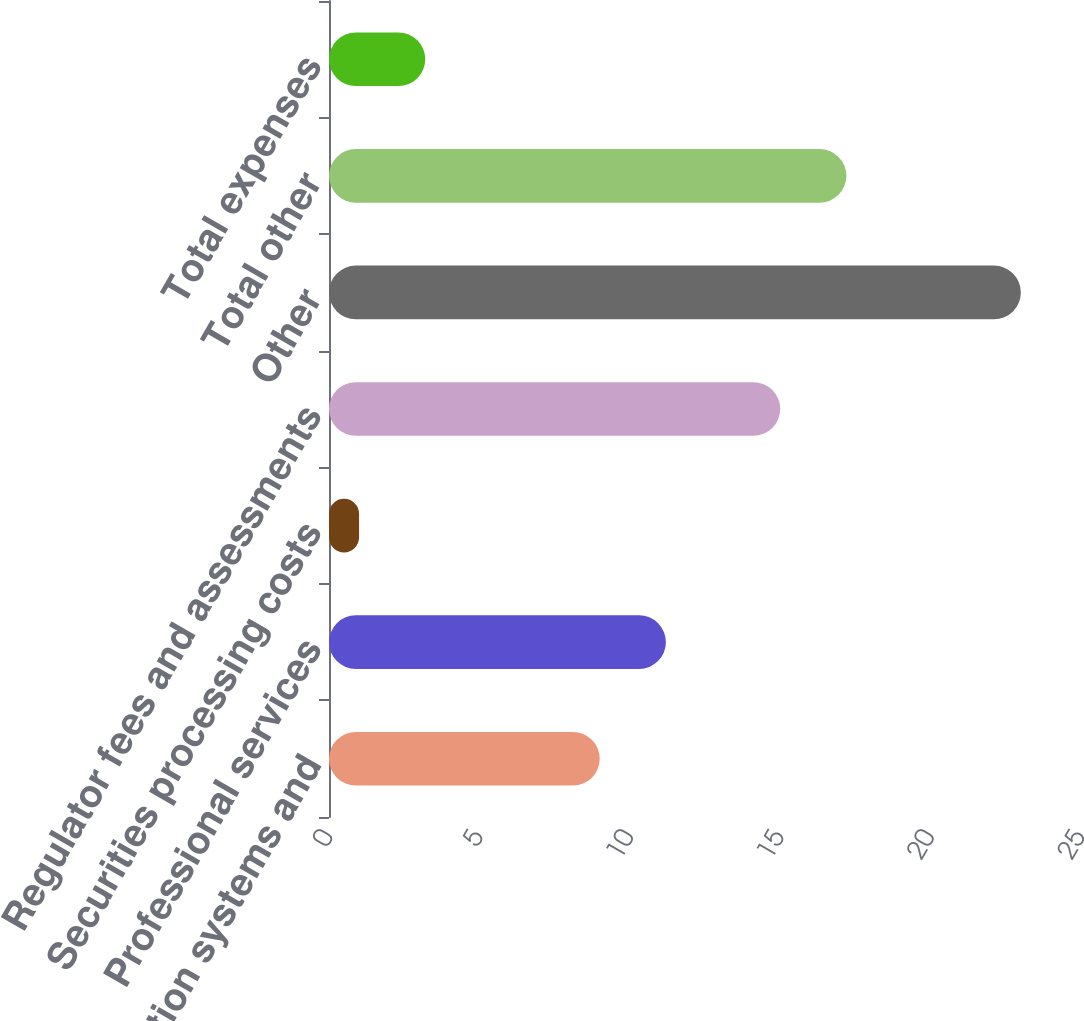Convert chart to OTSL. <chart><loc_0><loc_0><loc_500><loc_500><bar_chart><fcel>Information systems and<fcel>Professional services<fcel>Securities processing costs<fcel>Regulator fees and assessments<fcel>Other<fcel>Total other<fcel>Total expenses<nl><fcel>9<fcel>11.2<fcel>1<fcel>15<fcel>23<fcel>17.2<fcel>3.2<nl></chart> 